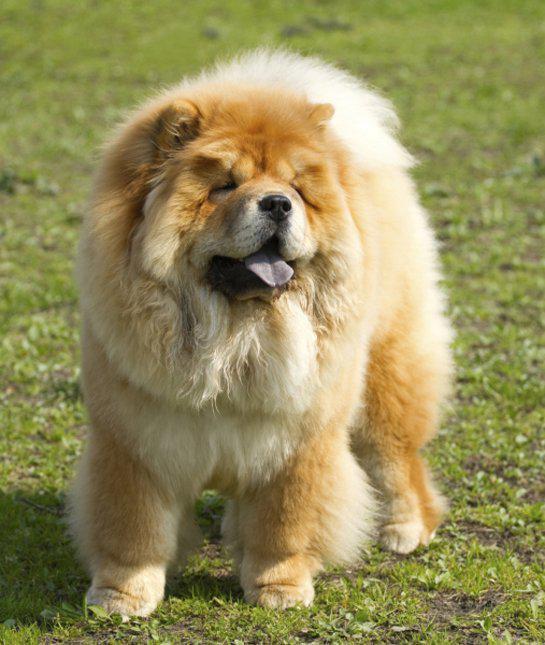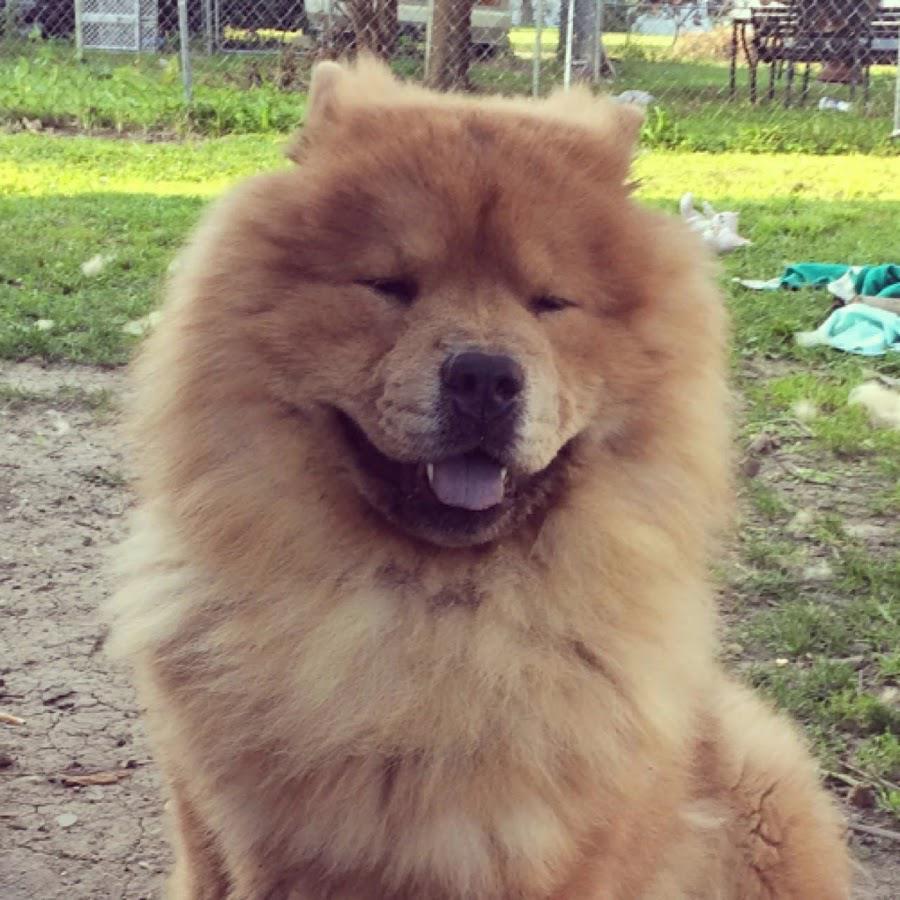The first image is the image on the left, the second image is the image on the right. Evaluate the accuracy of this statement regarding the images: "There are only two dogs total and none are laying down.". Is it true? Answer yes or no. Yes. 